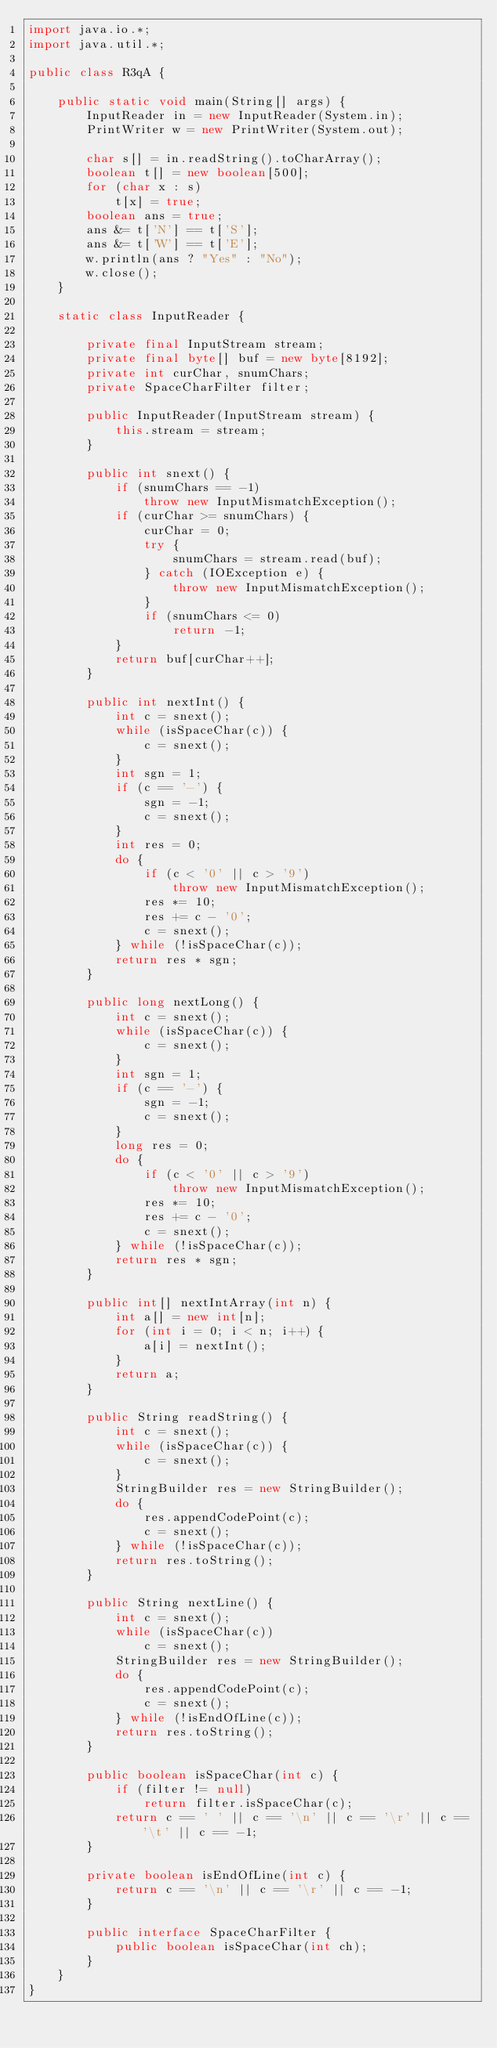Convert code to text. <code><loc_0><loc_0><loc_500><loc_500><_Java_>import java.io.*;
import java.util.*;

public class R3qA {

    public static void main(String[] args) {
        InputReader in = new InputReader(System.in);
        PrintWriter w = new PrintWriter(System.out);

        char s[] = in.readString().toCharArray();
        boolean t[] = new boolean[500];
        for (char x : s)
            t[x] = true;
        boolean ans = true;
        ans &= t['N'] == t['S'];
        ans &= t['W'] == t['E'];
        w.println(ans ? "Yes" : "No");
        w.close();
    }

    static class InputReader {

        private final InputStream stream;
        private final byte[] buf = new byte[8192];
        private int curChar, snumChars;
        private SpaceCharFilter filter;

        public InputReader(InputStream stream) {
            this.stream = stream;
        }

        public int snext() {
            if (snumChars == -1)
                throw new InputMismatchException();
            if (curChar >= snumChars) {
                curChar = 0;
                try {
                    snumChars = stream.read(buf);
                } catch (IOException e) {
                    throw new InputMismatchException();
                }
                if (snumChars <= 0)
                    return -1;
            }
            return buf[curChar++];
        }

        public int nextInt() {
            int c = snext();
            while (isSpaceChar(c)) {
                c = snext();
            }
            int sgn = 1;
            if (c == '-') {
                sgn = -1;
                c = snext();
            }
            int res = 0;
            do {
                if (c < '0' || c > '9')
                    throw new InputMismatchException();
                res *= 10;
                res += c - '0';
                c = snext();
            } while (!isSpaceChar(c));
            return res * sgn;
        }

        public long nextLong() {
            int c = snext();
            while (isSpaceChar(c)) {
                c = snext();
            }
            int sgn = 1;
            if (c == '-') {
                sgn = -1;
                c = snext();
            }
            long res = 0;
            do {
                if (c < '0' || c > '9')
                    throw new InputMismatchException();
                res *= 10;
                res += c - '0';
                c = snext();
            } while (!isSpaceChar(c));
            return res * sgn;
        }

        public int[] nextIntArray(int n) {
            int a[] = new int[n];
            for (int i = 0; i < n; i++) {
                a[i] = nextInt();
            }
            return a;
        }

        public String readString() {
            int c = snext();
            while (isSpaceChar(c)) {
                c = snext();
            }
            StringBuilder res = new StringBuilder();
            do {
                res.appendCodePoint(c);
                c = snext();
            } while (!isSpaceChar(c));
            return res.toString();
        }

        public String nextLine() {
            int c = snext();
            while (isSpaceChar(c))
                c = snext();
            StringBuilder res = new StringBuilder();
            do {
                res.appendCodePoint(c);
                c = snext();
            } while (!isEndOfLine(c));
            return res.toString();
        }

        public boolean isSpaceChar(int c) {
            if (filter != null)
                return filter.isSpaceChar(c);
            return c == ' ' || c == '\n' || c == '\r' || c == '\t' || c == -1;
        }

        private boolean isEndOfLine(int c) {
            return c == '\n' || c == '\r' || c == -1;
        }

        public interface SpaceCharFilter {
            public boolean isSpaceChar(int ch);
        }
    }
}</code> 